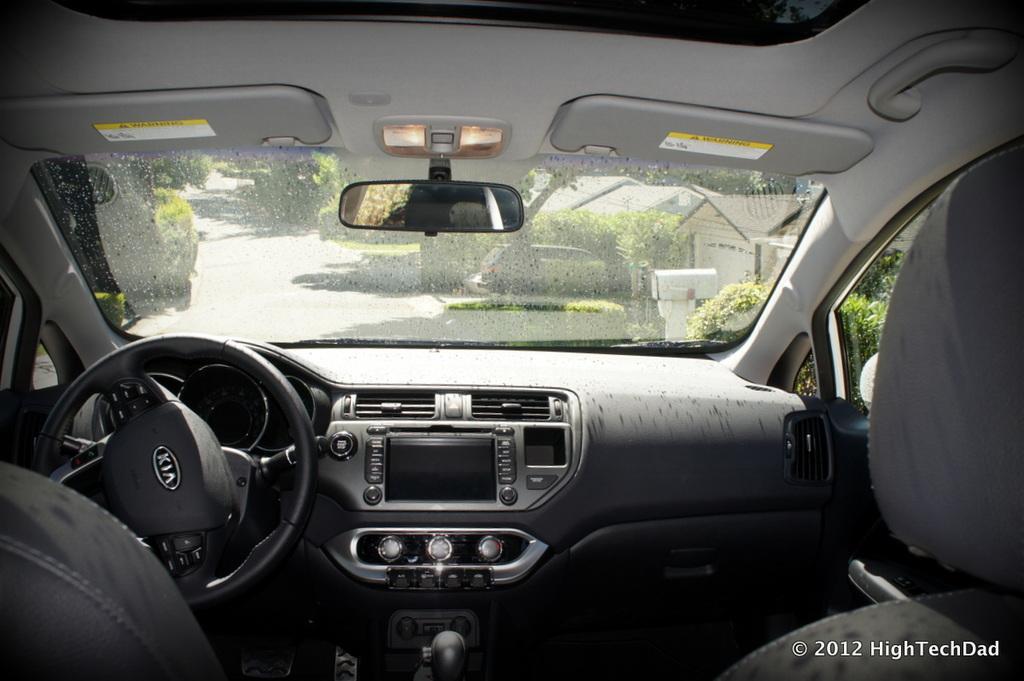How would you summarize this image in a sentence or two? This is the inside view of a vehicle. Here we can see a steering, seats, and a mirror. From the glass we can see plants, trees, houses, and road. 